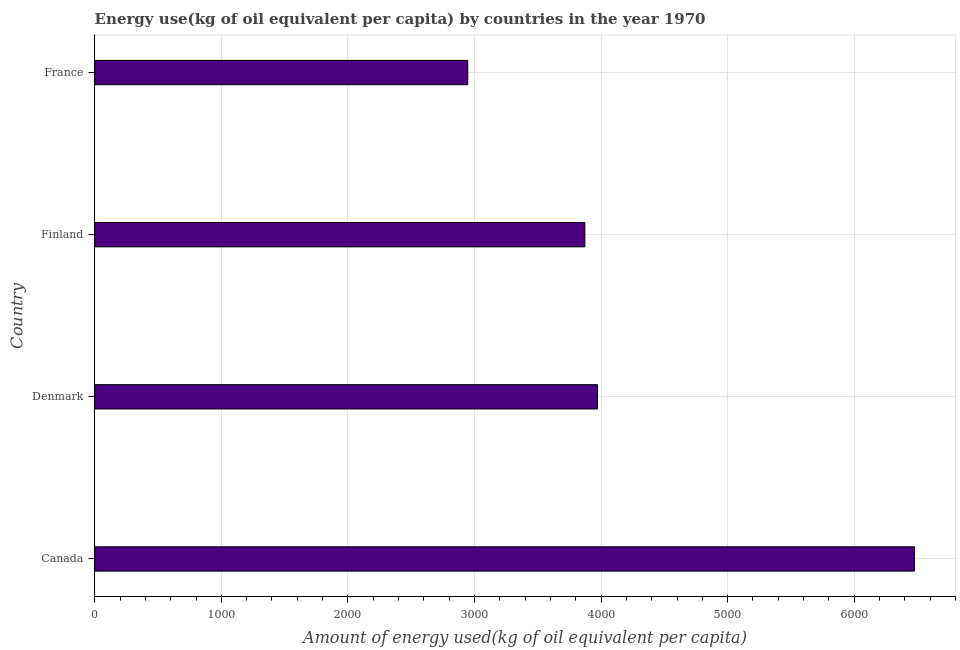Does the graph contain any zero values?
Ensure brevity in your answer.  No. Does the graph contain grids?
Your answer should be compact. Yes. What is the title of the graph?
Keep it short and to the point. Energy use(kg of oil equivalent per capita) by countries in the year 1970. What is the label or title of the X-axis?
Provide a short and direct response. Amount of energy used(kg of oil equivalent per capita). What is the amount of energy used in Finland?
Your answer should be very brief. 3872.22. Across all countries, what is the maximum amount of energy used?
Offer a very short reply. 6476.39. Across all countries, what is the minimum amount of energy used?
Keep it short and to the point. 2947.09. In which country was the amount of energy used minimum?
Your answer should be very brief. France. What is the sum of the amount of energy used?
Provide a short and direct response. 1.73e+04. What is the difference between the amount of energy used in Denmark and France?
Provide a short and direct response. 1024.34. What is the average amount of energy used per country?
Ensure brevity in your answer.  4316.78. What is the median amount of energy used?
Offer a terse response. 3921.83. What is the ratio of the amount of energy used in Canada to that in France?
Provide a succinct answer. 2.2. Is the amount of energy used in Denmark less than that in France?
Your response must be concise. No. What is the difference between the highest and the second highest amount of energy used?
Your answer should be very brief. 2504.96. Is the sum of the amount of energy used in Canada and Finland greater than the maximum amount of energy used across all countries?
Keep it short and to the point. Yes. What is the difference between the highest and the lowest amount of energy used?
Your response must be concise. 3529.3. Are all the bars in the graph horizontal?
Provide a short and direct response. Yes. How many countries are there in the graph?
Make the answer very short. 4. Are the values on the major ticks of X-axis written in scientific E-notation?
Offer a very short reply. No. What is the Amount of energy used(kg of oil equivalent per capita) of Canada?
Provide a succinct answer. 6476.39. What is the Amount of energy used(kg of oil equivalent per capita) in Denmark?
Keep it short and to the point. 3971.43. What is the Amount of energy used(kg of oil equivalent per capita) of Finland?
Ensure brevity in your answer.  3872.22. What is the Amount of energy used(kg of oil equivalent per capita) in France?
Ensure brevity in your answer.  2947.09. What is the difference between the Amount of energy used(kg of oil equivalent per capita) in Canada and Denmark?
Make the answer very short. 2504.96. What is the difference between the Amount of energy used(kg of oil equivalent per capita) in Canada and Finland?
Provide a short and direct response. 2604.17. What is the difference between the Amount of energy used(kg of oil equivalent per capita) in Canada and France?
Provide a succinct answer. 3529.3. What is the difference between the Amount of energy used(kg of oil equivalent per capita) in Denmark and Finland?
Your answer should be very brief. 99.21. What is the difference between the Amount of energy used(kg of oil equivalent per capita) in Denmark and France?
Make the answer very short. 1024.34. What is the difference between the Amount of energy used(kg of oil equivalent per capita) in Finland and France?
Ensure brevity in your answer.  925.13. What is the ratio of the Amount of energy used(kg of oil equivalent per capita) in Canada to that in Denmark?
Your response must be concise. 1.63. What is the ratio of the Amount of energy used(kg of oil equivalent per capita) in Canada to that in Finland?
Your answer should be compact. 1.67. What is the ratio of the Amount of energy used(kg of oil equivalent per capita) in Canada to that in France?
Your response must be concise. 2.2. What is the ratio of the Amount of energy used(kg of oil equivalent per capita) in Denmark to that in Finland?
Provide a succinct answer. 1.03. What is the ratio of the Amount of energy used(kg of oil equivalent per capita) in Denmark to that in France?
Your answer should be very brief. 1.35. What is the ratio of the Amount of energy used(kg of oil equivalent per capita) in Finland to that in France?
Offer a very short reply. 1.31. 